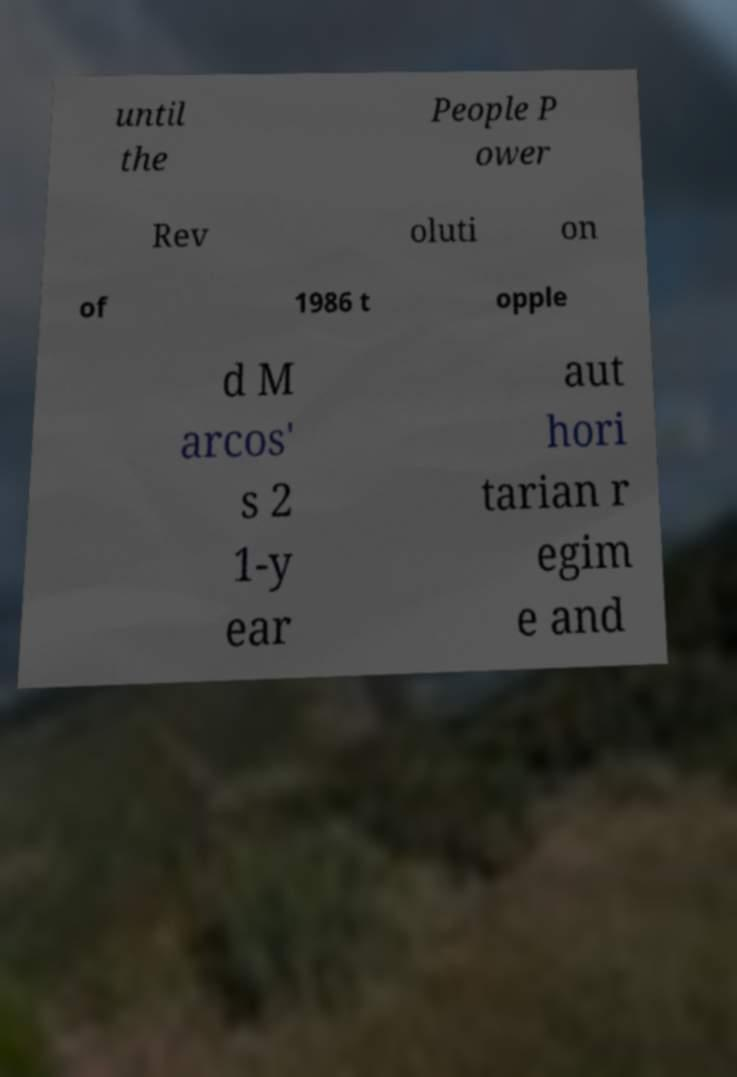Can you read and provide the text displayed in the image?This photo seems to have some interesting text. Can you extract and type it out for me? until the People P ower Rev oluti on of 1986 t opple d M arcos' s 2 1-y ear aut hori tarian r egim e and 